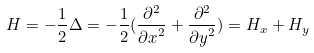Convert formula to latex. <formula><loc_0><loc_0><loc_500><loc_500>H = - \frac { 1 } { 2 } \Delta = - \frac { 1 } { 2 } ( \frac { \partial ^ { 2 } } { { \partial x } ^ { 2 } } + \frac { \partial ^ { 2 } } { { \partial y } ^ { 2 } } ) = H _ { x } + H _ { y }</formula> 